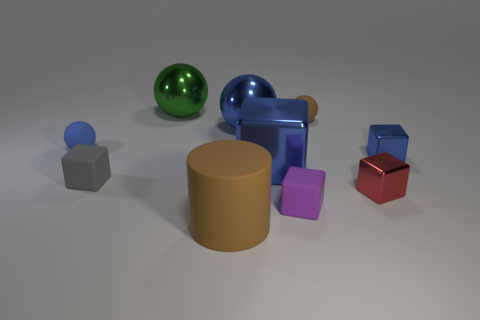Subtract all tiny blue matte spheres. How many spheres are left? 3 Subtract all balls. How many objects are left? 6 Subtract 0 yellow cylinders. How many objects are left? 10 Subtract 5 cubes. How many cubes are left? 0 Subtract all blue blocks. Subtract all yellow spheres. How many blocks are left? 3 Subtract all gray blocks. How many brown balls are left? 1 Subtract all small matte objects. Subtract all big gray cylinders. How many objects are left? 6 Add 9 gray matte things. How many gray matte things are left? 10 Add 3 yellow metal things. How many yellow metal things exist? 3 Subtract all purple cubes. How many cubes are left? 4 